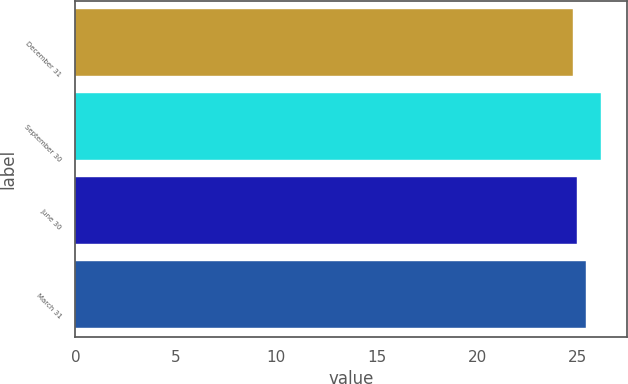Convert chart to OTSL. <chart><loc_0><loc_0><loc_500><loc_500><bar_chart><fcel>December 31<fcel>September 30<fcel>June 30<fcel>March 31<nl><fcel>24.8<fcel>26.17<fcel>24.99<fcel>25.44<nl></chart> 